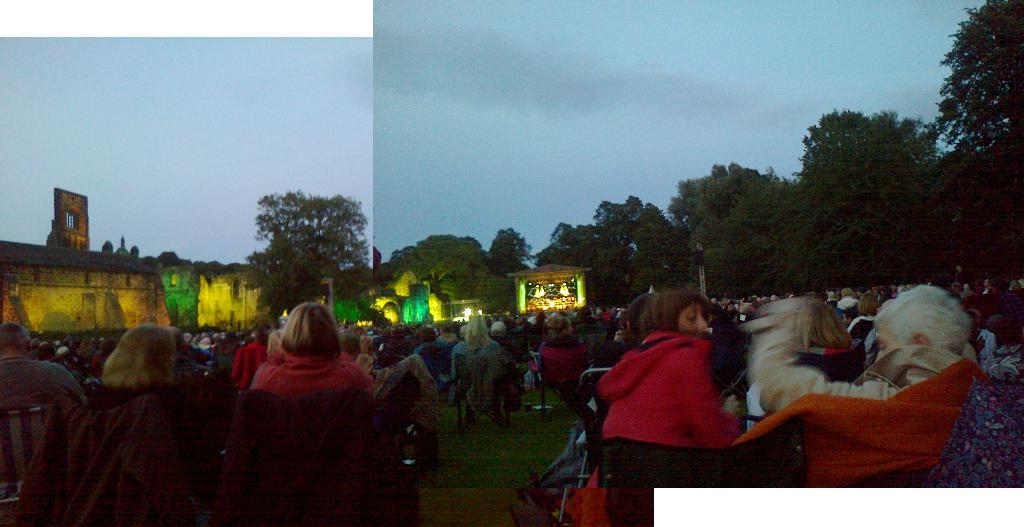How many people are in the image? There is a group of people in the image. What are the people doing in the image? The people are sitting on chairs in the image. What can be seen in the background of the image? There are trees, buildings, and lights visible in the background of the image. What type of art is being displayed on the statement of the representative in the image? There is no art, statement, or representative present in the image. 